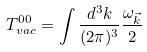Convert formula to latex. <formula><loc_0><loc_0><loc_500><loc_500>T _ { v a c } ^ { 0 0 } = \int \frac { d ^ { 3 } k } { ( 2 \pi ) ^ { 3 } } \frac { \omega _ { \vec { k } } } { 2 }</formula> 